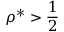<formula> <loc_0><loc_0><loc_500><loc_500>\rho ^ { * } > \frac { 1 } { 2 }</formula> 